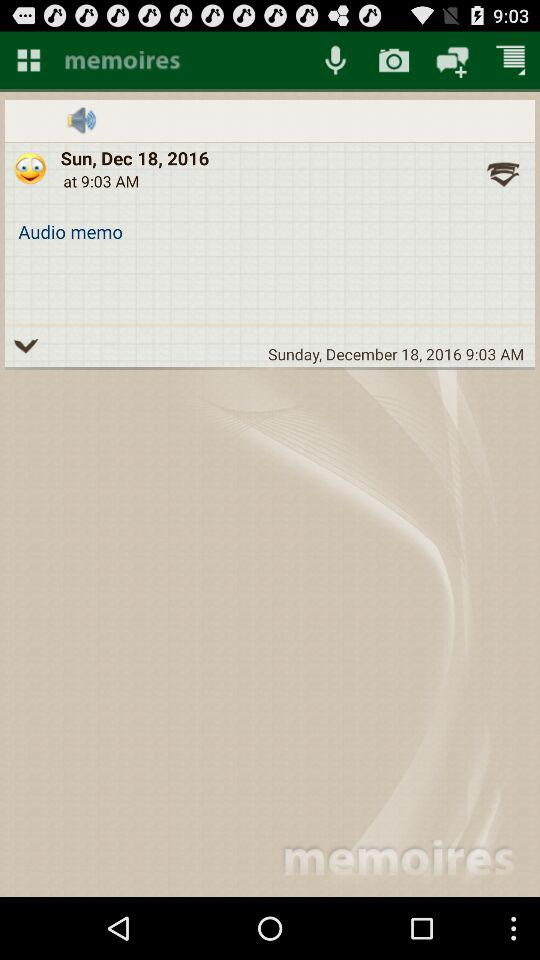What is the day given? The given day is Sunday. 